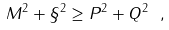<formula> <loc_0><loc_0><loc_500><loc_500>M ^ { 2 } + \S ^ { 2 } \geq P ^ { 2 } + Q ^ { 2 } \ , \\</formula> 